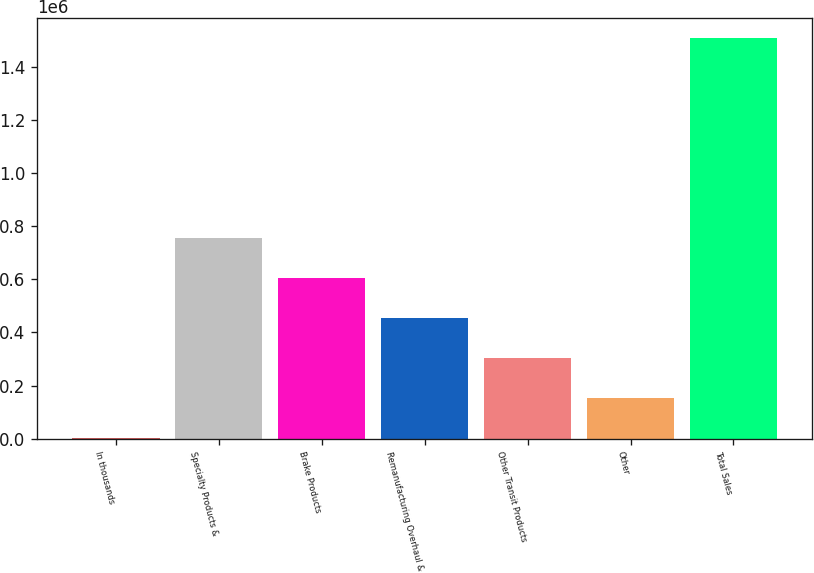<chart> <loc_0><loc_0><loc_500><loc_500><bar_chart><fcel>In thousands<fcel>Specialty Products &<fcel>Brake Products<fcel>Remanufacturing Overhaul &<fcel>Other Transit Products<fcel>Other<fcel>Total Sales<nl><fcel>2010<fcel>754511<fcel>604011<fcel>453511<fcel>303010<fcel>152510<fcel>1.50701e+06<nl></chart> 